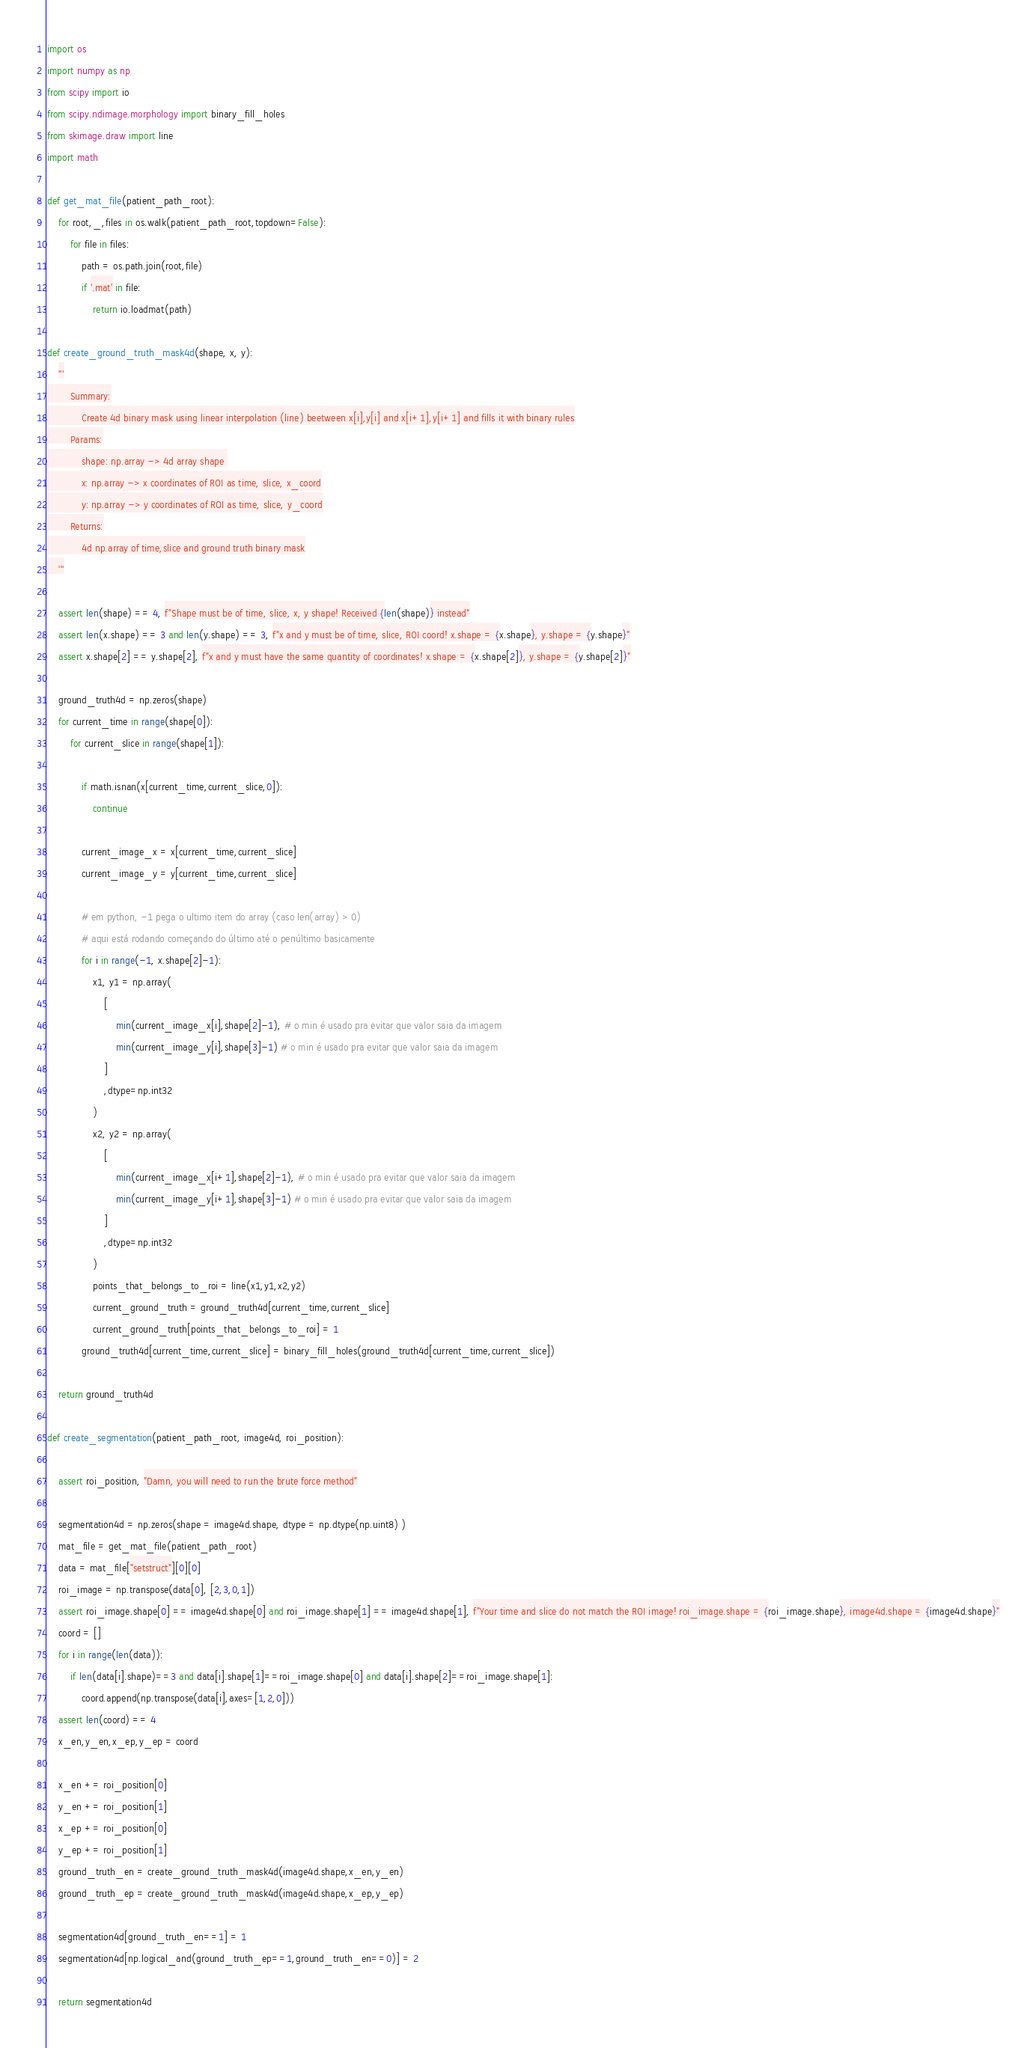Convert code to text. <code><loc_0><loc_0><loc_500><loc_500><_Python_>import os
import numpy as np
from scipy import io
from scipy.ndimage.morphology import binary_fill_holes
from skimage.draw import line
import math

def get_mat_file(patient_path_root):
    for root,_,files in os.walk(patient_path_root,topdown=False):
        for file in files:
            path = os.path.join(root,file)
            if '.mat' in file:
                return io.loadmat(path)

def create_ground_truth_mask4d(shape, x, y):
    '''
        Summary:
            Create 4d binary mask using linear interpolation (line) beetween x[i],y[i] and x[i+1],y[i+1] and fills it with binary rules
        Params:
            shape: np.array -> 4d array shape 
            x: np.array -> x coordinates of ROI as time, slice, x_coord
            y: np.array -> y coordinates of ROI as time, slice, y_coord
        Returns:
            4d np.array of time,slice and ground truth binary mask
    '''

    assert len(shape) == 4, f"Shape must be of time, slice, x, y shape! Received {len(shape)} instead"
    assert len(x.shape) == 3 and len(y.shape) == 3, f"x and y must be of time, slice, ROI coord! x.shape = {x.shape}, y.shape = {y.shape}"
    assert x.shape[2] == y.shape[2], f"x and y must have the same quantity of coordinates! x.shape = {x.shape[2]}, y.shape = {y.shape[2]}"

    ground_truth4d = np.zeros(shape)
    for current_time in range(shape[0]):
        for current_slice in range(shape[1]):

            if math.isnan(x[current_time,current_slice,0]):
                continue

            current_image_x = x[current_time,current_slice]
            current_image_y = y[current_time,current_slice]

            # em python, -1 pega o ultimo item do array (caso len(array) > 0)
            # aqui está rodando começando do último até o penúltimo basicamente
            for i in range(-1, x.shape[2]-1):
                x1, y1 = np.array(
                    [
                        min(current_image_x[i],shape[2]-1), # o min é usado pra evitar que valor saia da imagem
                        min(current_image_y[i],shape[3]-1) # o min é usado pra evitar que valor saia da imagem
                    ]
                    ,dtype=np.int32
                )
                x2, y2 = np.array(
                    [
                        min(current_image_x[i+1],shape[2]-1), # o min é usado pra evitar que valor saia da imagem
                        min(current_image_y[i+1],shape[3]-1) # o min é usado pra evitar que valor saia da imagem
                    ]
                    ,dtype=np.int32
                )
                points_that_belongs_to_roi = line(x1,y1,x2,y2)
                current_ground_truth = ground_truth4d[current_time,current_slice]
                current_ground_truth[points_that_belongs_to_roi] = 1            
            ground_truth4d[current_time,current_slice] = binary_fill_holes(ground_truth4d[current_time,current_slice])

    return ground_truth4d

def create_segmentation(patient_path_root, image4d, roi_position):

    assert roi_position, "Damn, you will need to run the brute force method"

    segmentation4d = np.zeros(shape = image4d.shape, dtype = np.dtype(np.uint8) )
    mat_file = get_mat_file(patient_path_root)
    data = mat_file["setstruct"][0][0]
    roi_image = np.transpose(data[0], [2,3,0,1])
    assert roi_image.shape[0] == image4d.shape[0] and roi_image.shape[1] == image4d.shape[1], f"Your time and slice do not match the ROI image! roi_image.shape = {roi_image.shape}, image4d.shape = {image4d.shape}"
    coord = []
    for i in range(len(data)):
        if len(data[i].shape)==3 and data[i].shape[1]==roi_image.shape[0] and data[i].shape[2]==roi_image.shape[1]:
            coord.append(np.transpose(data[i],axes=[1,2,0]))
    assert len(coord) == 4
    x_en,y_en,x_ep,y_ep = coord

    x_en += roi_position[0]
    y_en += roi_position[1]
    x_ep += roi_position[0]
    y_ep += roi_position[1]
    ground_truth_en = create_ground_truth_mask4d(image4d.shape,x_en,y_en)
    ground_truth_ep = create_ground_truth_mask4d(image4d.shape,x_ep,y_ep)

    segmentation4d[ground_truth_en==1] = 1
    segmentation4d[np.logical_and(ground_truth_ep==1,ground_truth_en==0)] = 2

    return segmentation4d</code> 